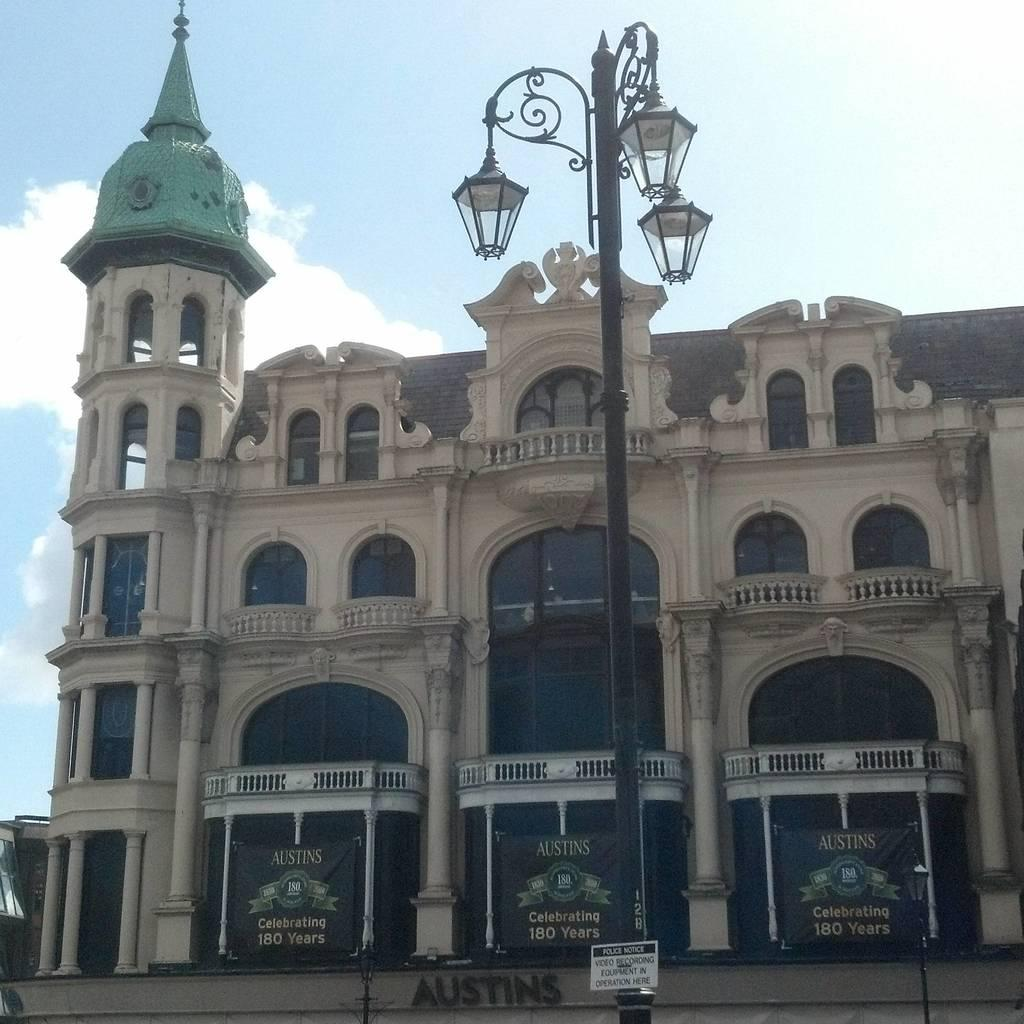<image>
Describe the image concisely. an exterior of Austin's stores Celebrating 180 years 